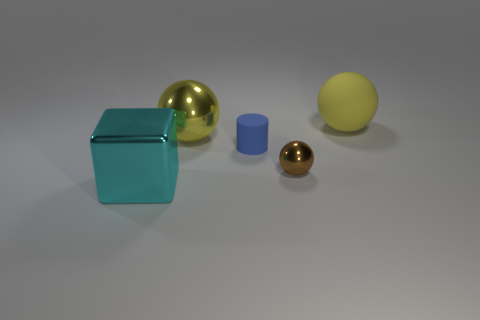There is a thing that is both in front of the small matte cylinder and left of the blue matte thing; what is its material?
Provide a succinct answer. Metal. How many objects are either big cyan rubber blocks or metal balls?
Provide a short and direct response. 2. Is the number of brown metallic objects greater than the number of blue shiny blocks?
Ensure brevity in your answer.  Yes. What is the size of the shiny sphere that is to the right of the big metallic thing to the right of the cyan block?
Provide a succinct answer. Small. The large rubber object that is the same shape as the brown metallic thing is what color?
Provide a succinct answer. Yellow. What is the size of the cyan shiny cube?
Provide a short and direct response. Large. How many cylinders are tiny things or red matte things?
Keep it short and to the point. 1. There is a yellow rubber object that is the same shape as the tiny metal thing; what is its size?
Keep it short and to the point. Large. What number of big yellow balls are there?
Your answer should be compact. 2. Does the tiny metal object have the same shape as the cyan metallic object in front of the small brown ball?
Your answer should be very brief. No. 